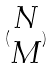<formula> <loc_0><loc_0><loc_500><loc_500>( \begin{matrix} N \\ M \end{matrix} )</formula> 